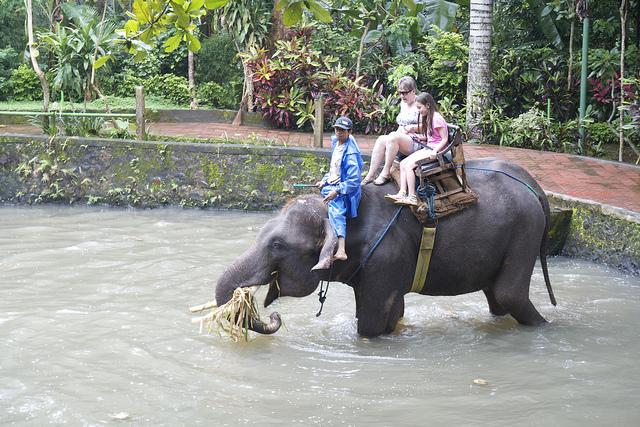How many people are seated on top of the elephant eating in the pool? three 